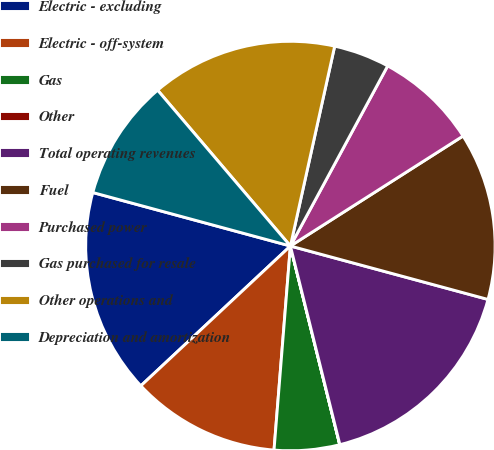Convert chart to OTSL. <chart><loc_0><loc_0><loc_500><loc_500><pie_chart><fcel>Electric - excluding<fcel>Electric - off-system<fcel>Gas<fcel>Other<fcel>Total operating revenues<fcel>Fuel<fcel>Purchased power<fcel>Gas purchased for resale<fcel>Other operations and<fcel>Depreciation and amortization<nl><fcel>16.17%<fcel>11.76%<fcel>5.15%<fcel>0.01%<fcel>16.91%<fcel>13.23%<fcel>8.09%<fcel>4.41%<fcel>14.7%<fcel>9.56%<nl></chart> 